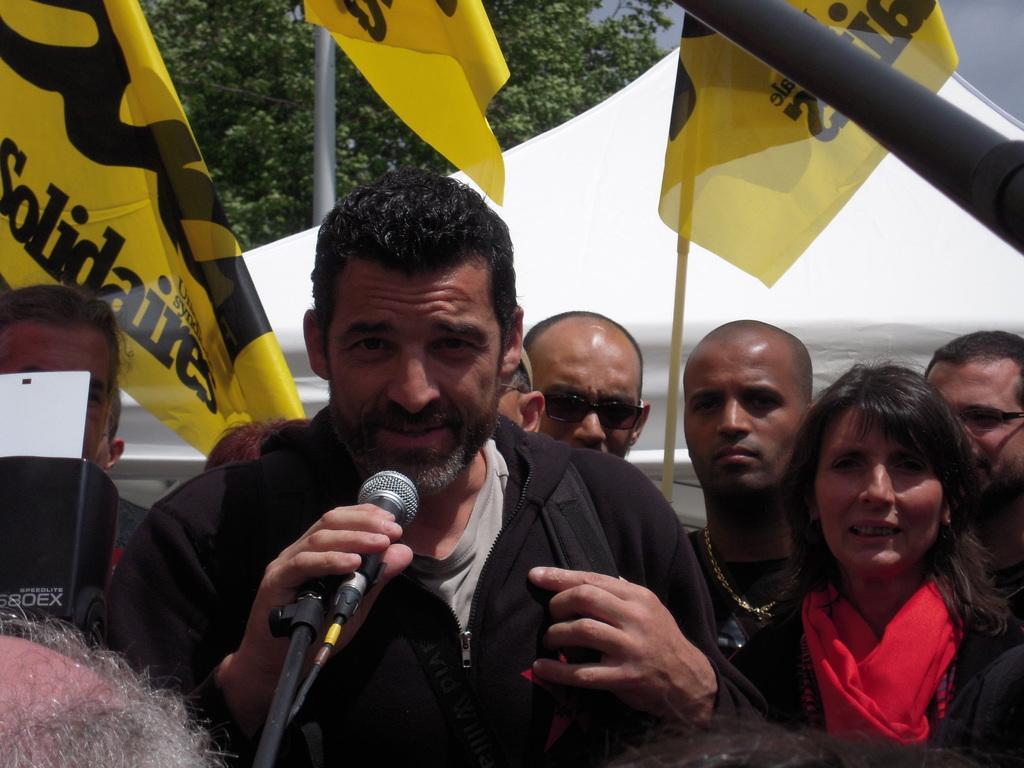Can you describe this image briefly? In this picture we can see a group of people standing and a man among them is holding a mic. 